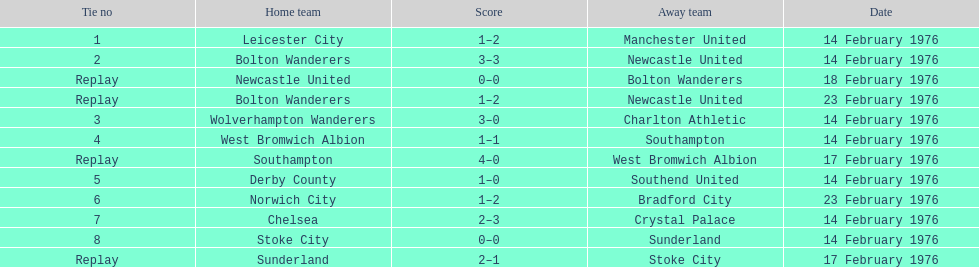What was the goal difference in the game on february 18th? 0. Help me parse the entirety of this table. {'header': ['Tie no', 'Home team', 'Score', 'Away team', 'Date'], 'rows': [['1', 'Leicester City', '1–2', 'Manchester United', '14 February 1976'], ['2', 'Bolton Wanderers', '3–3', 'Newcastle United', '14 February 1976'], ['Replay', 'Newcastle United', '0–0', 'Bolton Wanderers', '18 February 1976'], ['Replay', 'Bolton Wanderers', '1–2', 'Newcastle United', '23 February 1976'], ['3', 'Wolverhampton Wanderers', '3–0', 'Charlton Athletic', '14 February 1976'], ['4', 'West Bromwich Albion', '1–1', 'Southampton', '14 February 1976'], ['Replay', 'Southampton', '4–0', 'West Bromwich Albion', '17 February 1976'], ['5', 'Derby County', '1–0', 'Southend United', '14 February 1976'], ['6', 'Norwich City', '1–2', 'Bradford City', '23 February 1976'], ['7', 'Chelsea', '2–3', 'Crystal Palace', '14 February 1976'], ['8', 'Stoke City', '0–0', 'Sunderland', '14 February 1976'], ['Replay', 'Sunderland', '2–1', 'Stoke City', '17 February 1976']]} 